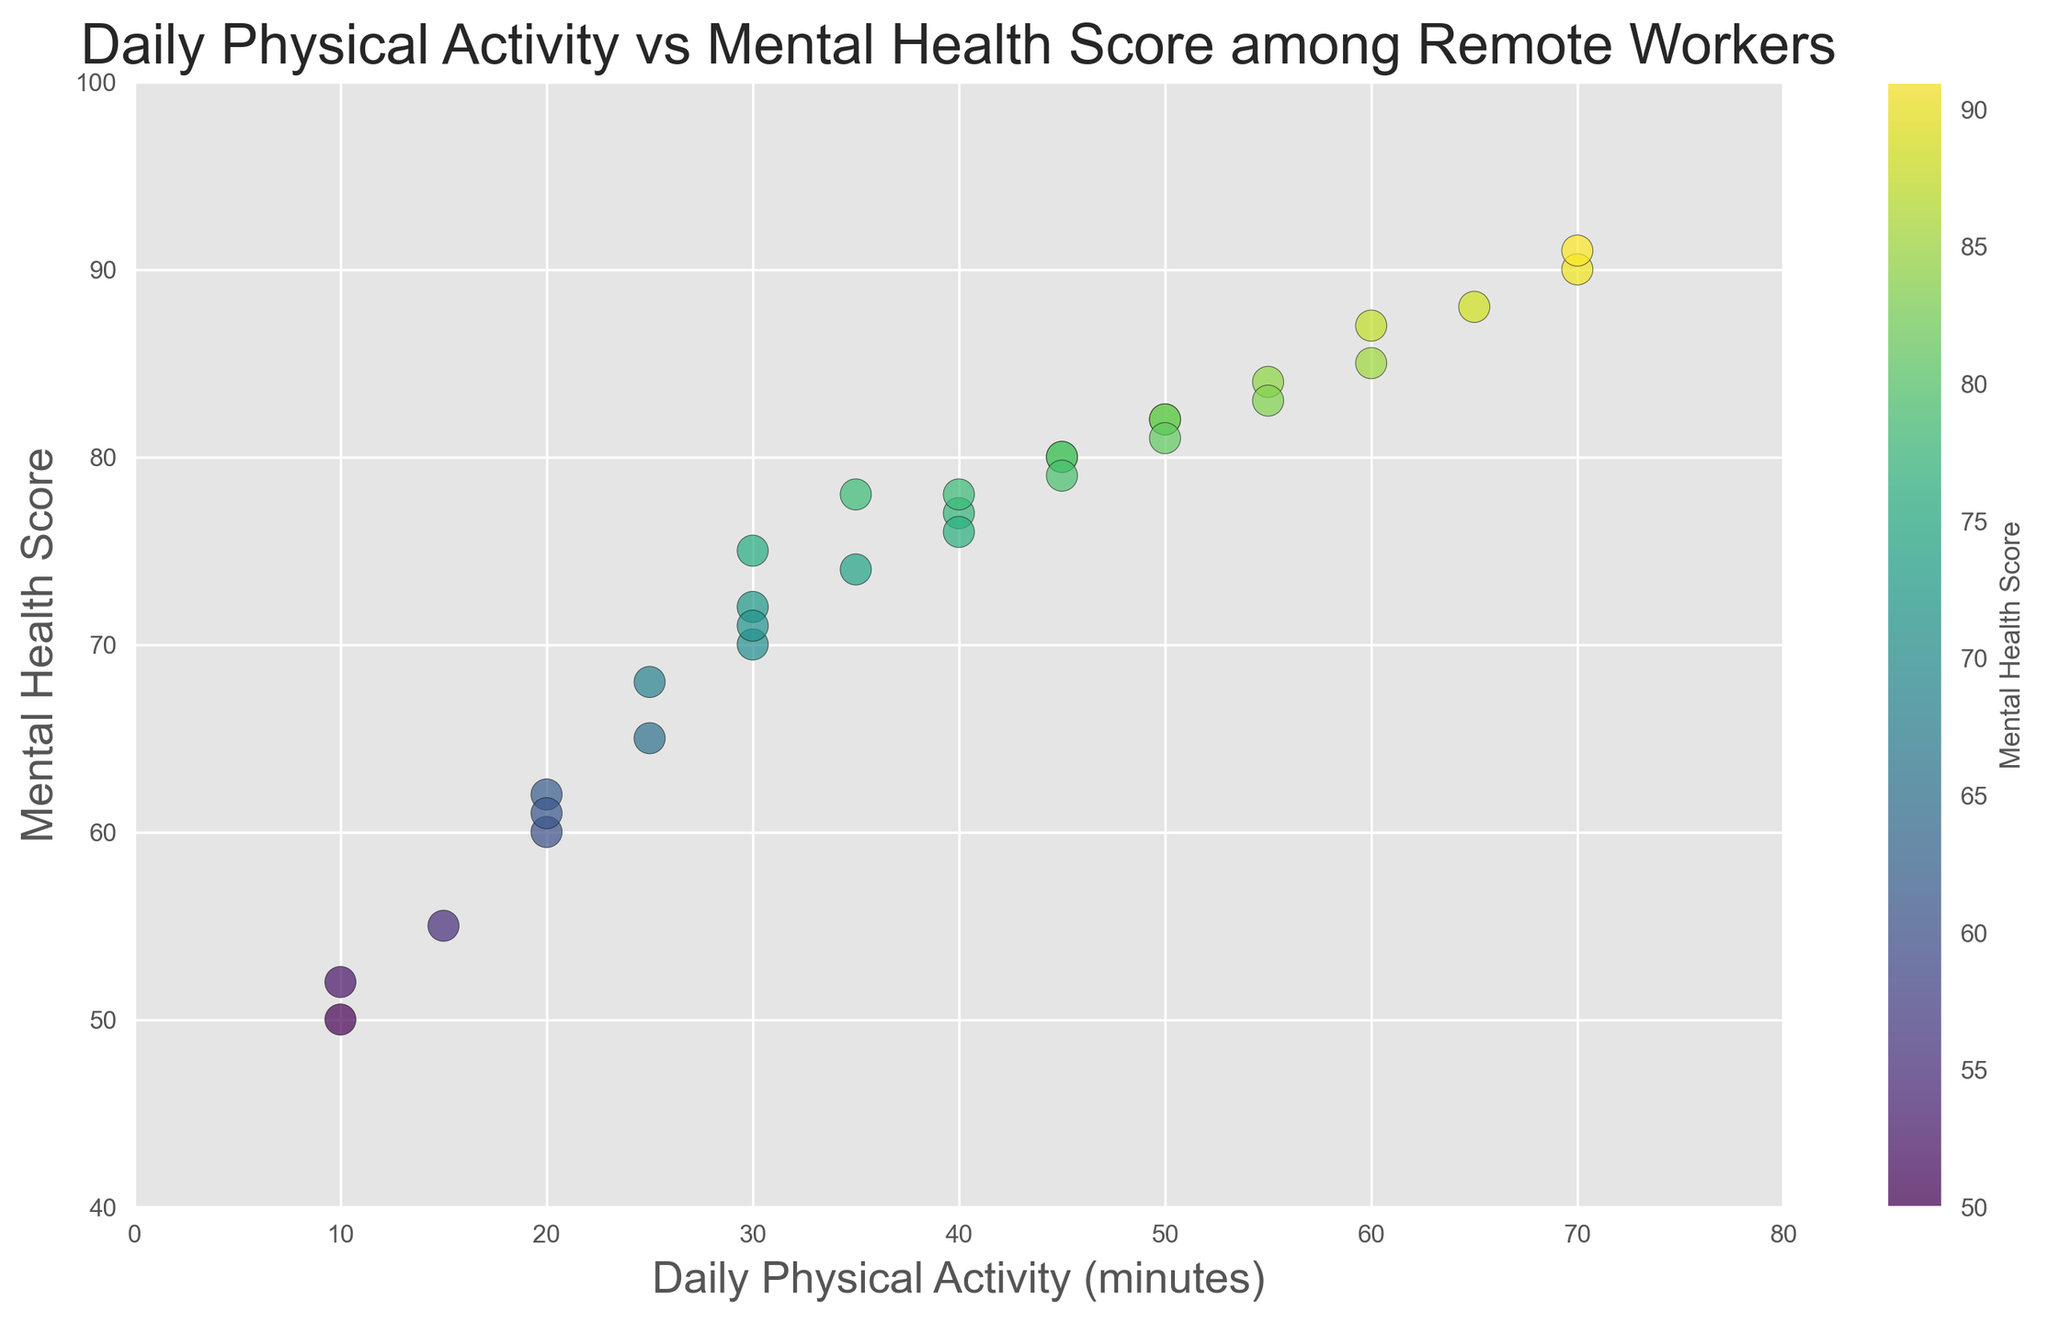What's the minimum value for the Mental Health Score? To find the minimum value for the Mental Health Score, look at the scatter plot and identify the lowest point on the vertical axis (Mental Health Score).
Answer: 50 Which data point represents the highest Mental Health Score? To identify the data point with the highest Mental Health Score, find the point furthest up the vertical axis. The corresponding 'Daily Physical Activity' value will also be shown.
Answer: 70 minutes, 91 score What's the average Daily Physical Activity among remote workers with a Mental Health Score of 80 or above? Identify all points with a Mental Health Score of 80 or above and sum their 'Daily Physical Activity' values. Divide this sum by the number of such points. The values are 45, 60, 50, 70, 55, 50, 65, 55 (sum = 450), so the average is 450/8.
Answer: 56.25 minutes Is there a data point where both Daily Physical Activity and Mental Health Score are below average? Calculate the averages: For Daily Physical Activity, sum all values (1100) and divide by the number of points (30), average = 36.67; for Mental Health Score, sum all values (2235) and divide by the number of points (30), average = 74.5. Look at the scatter plot to find any points below both these averages.
Answer: Yes, (10, 50), (10, 52), (15, 55), (20, 60), (20, 61), (20, 62), (25, 65), (25, 68) What is the difference in Mental Health Scores between the points with the highest and lowest Daily Physical Activity? Identify the points with the highest (70 minutes) and lowest (10 minutes) Daily Physical Activity. Subtract the Mental Health Score at 10 minutes (52) from the score at 70 minutes (91). 91 - 52.
Answer: 39 Which visual attribute indicates the Mental Health Score on the scatter plot? Identify the color gradient in the scatter plot. Look at the color bar indicating Mental Health Scores, which progresses from one color to another as scores increase.
Answer: Color of the dot Are there more data points with Daily Physical Activity above 40 minutes or below 40 minutes? Count the number of data points above and below the 40-minute mark on the scatter plot. Above: (45, 45, 50, 50, 55, 55, 60, 65, 70, 70), Below: (10, 10, 15, 20, 20, 20, 25, 25, 30, 30, 30, 30, 35, 35, 35, 40, 40, 40).
Answer: More below (18 to 10) Does there appear to be a positive correlation between Daily Physical Activity and Mental Health Score? Look at the general trend in the scatter plot, where increases in Daily Physical Activity are associated with increases in the Mental Health Score.
Answer: Yes How many points have a Daily Physical Activity of exactly 50 minutes, and what are their corresponding Mental Health Scores? Identify the points on the scatter plot that align vertically with 50 on the Daily Physical Activity axis.
Answer: 3 points (50, 82), (50, 81), (50, 82) 